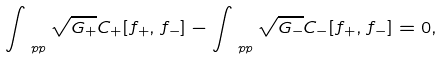<formula> <loc_0><loc_0><loc_500><loc_500>\int _ { \ p p } \sqrt { G _ { + } } C _ { + } [ f _ { + } , f _ { - } ] - \int _ { \ p p } \sqrt { G _ { - } } C _ { - } [ f _ { + } , f _ { - } ] = 0 ,</formula> 